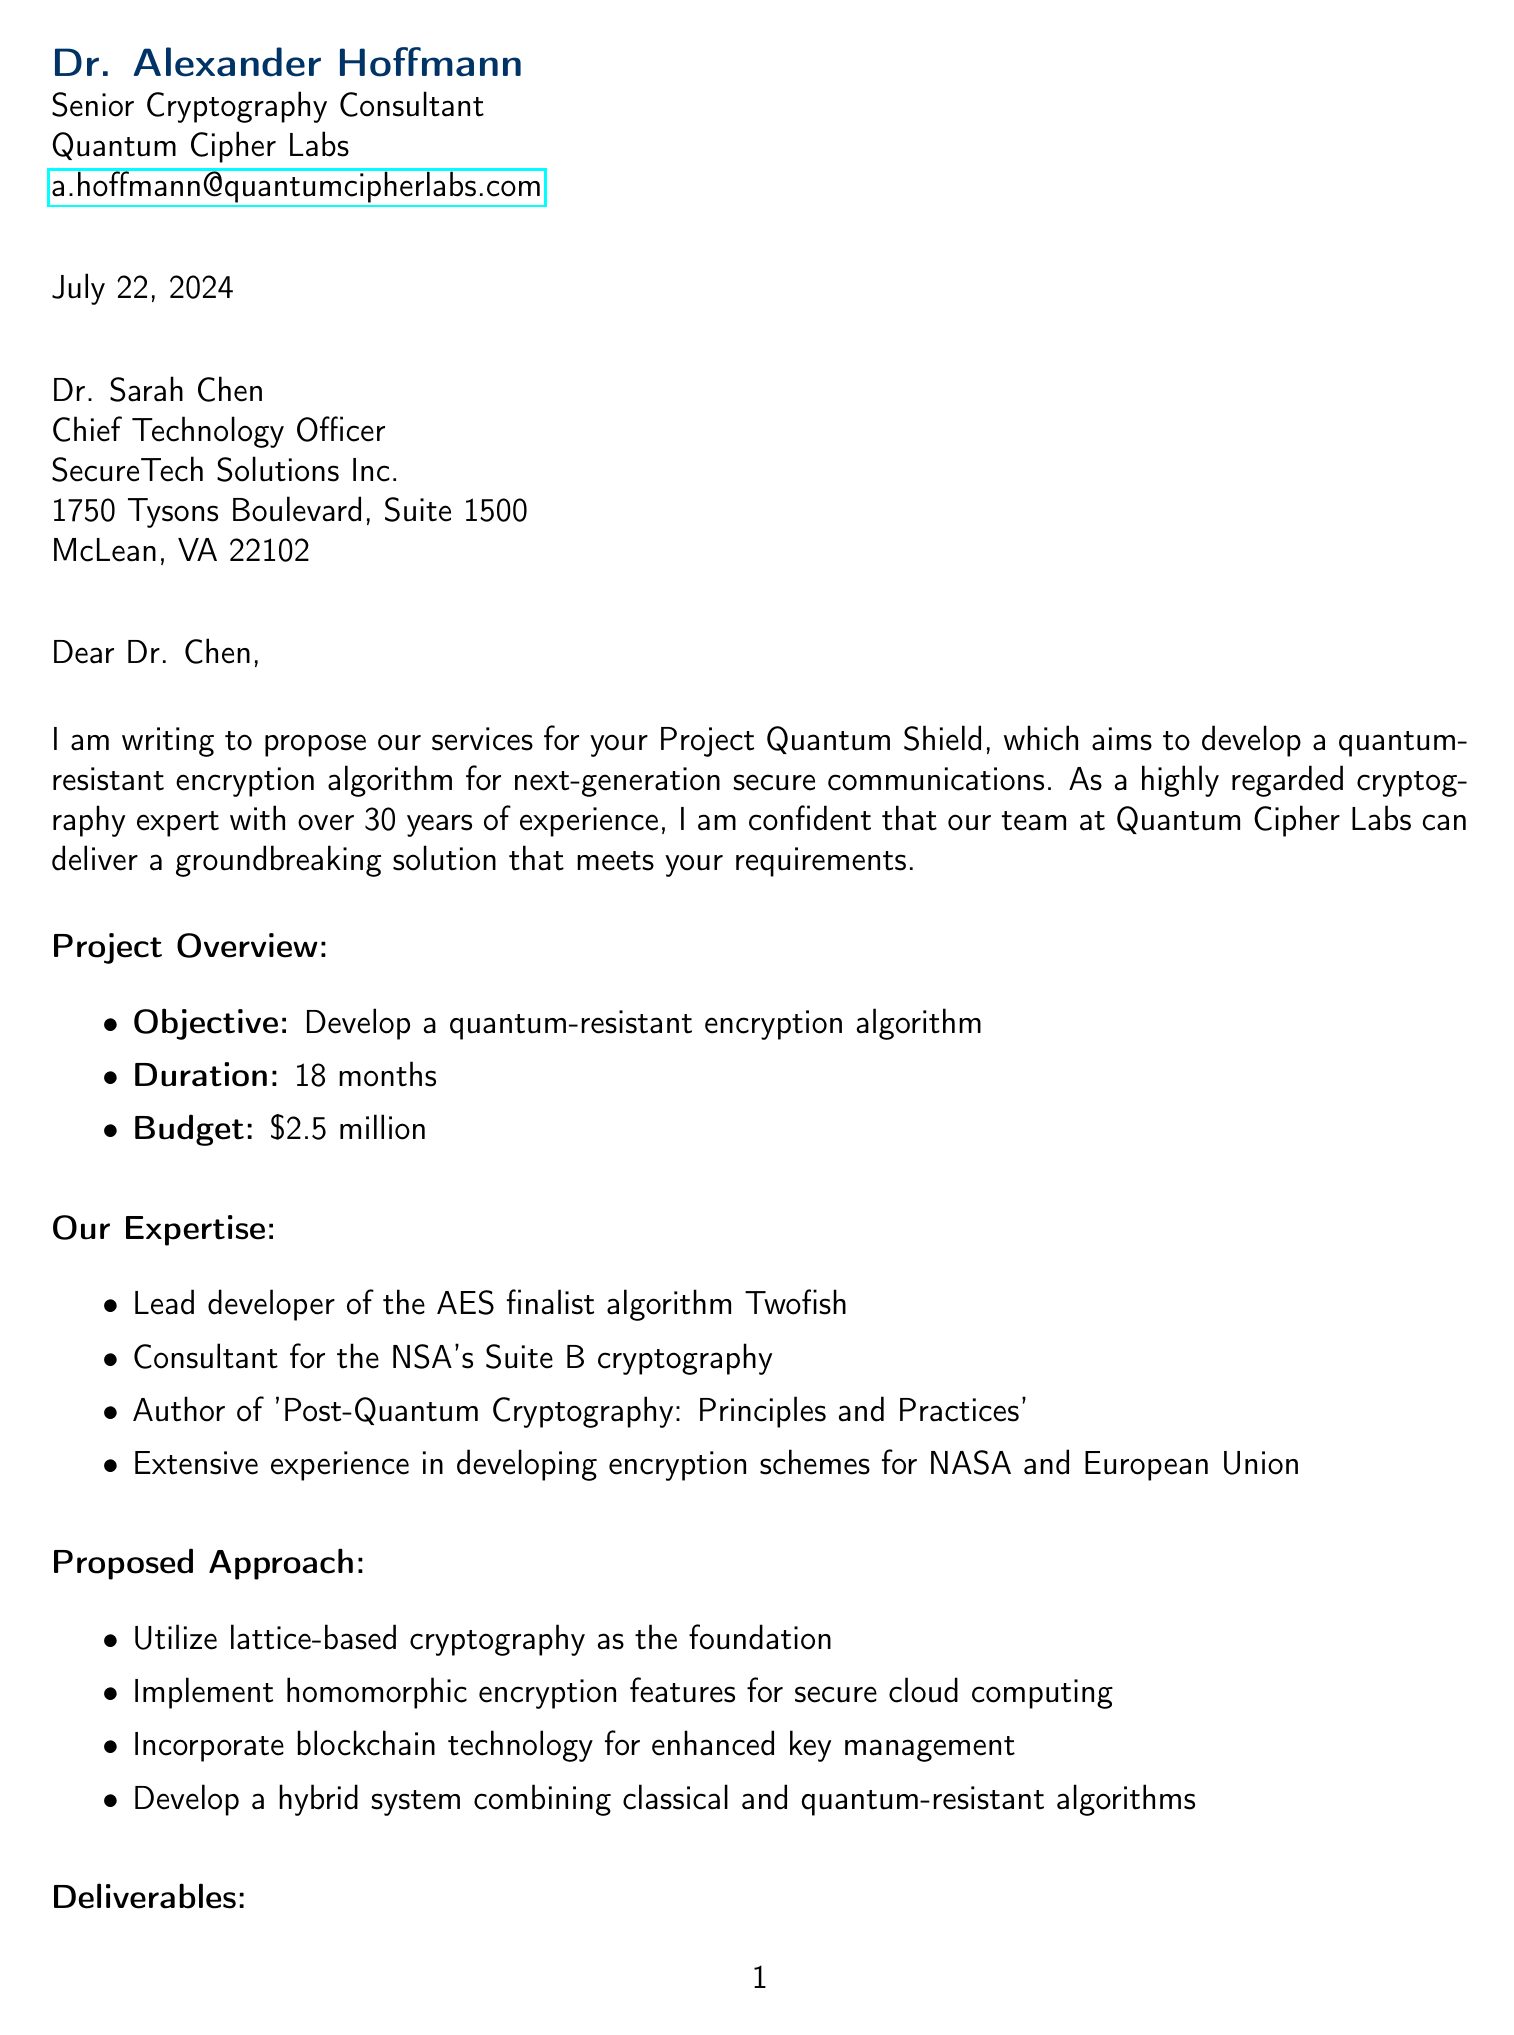what is the project name? The project name is mentioned in the document as "Project Quantum Shield."
Answer: Project Quantum Shield who is the sender of the letter? The sender is identified as Dr. Alexander Hoffmann, the Senior Cryptography Consultant.
Answer: Dr. Alexander Hoffmann what is the duration of the project? The duration is specified in the document as 18 months.
Answer: 18 months which position does Dr. Sarah Chen hold? The letter states that Dr. Sarah Chen is the Chief Technology Officer.
Answer: Chief Technology Officer what is the proposed budget for the project? The budget proposed is mentioned as $2.5 million.
Answer: $2.5 million how many months are allocated for implementation and testing? The document states that 8 months are allocated for implementation and testing.
Answer: 8 months what type of encryption algorithm is being developed? The letter indicates that a quantum-resistant encryption algorithm is being developed.
Answer: quantum-resistant encryption algorithm who will be the Lead Cryptographer in the project? The Lead Cryptographer is specified as Dr. Alexander Hoffmann.
Answer: Dr. Alexander Hoffmann what are the deliverables mentioned in the proposal? The deliverables include a comprehensive white paper, proof-of-concept implementation, rigorous security analysis, and documentation.
Answer: Comprehensive white paper, proof-of-concept implementation, rigorous security analysis, and documentation 